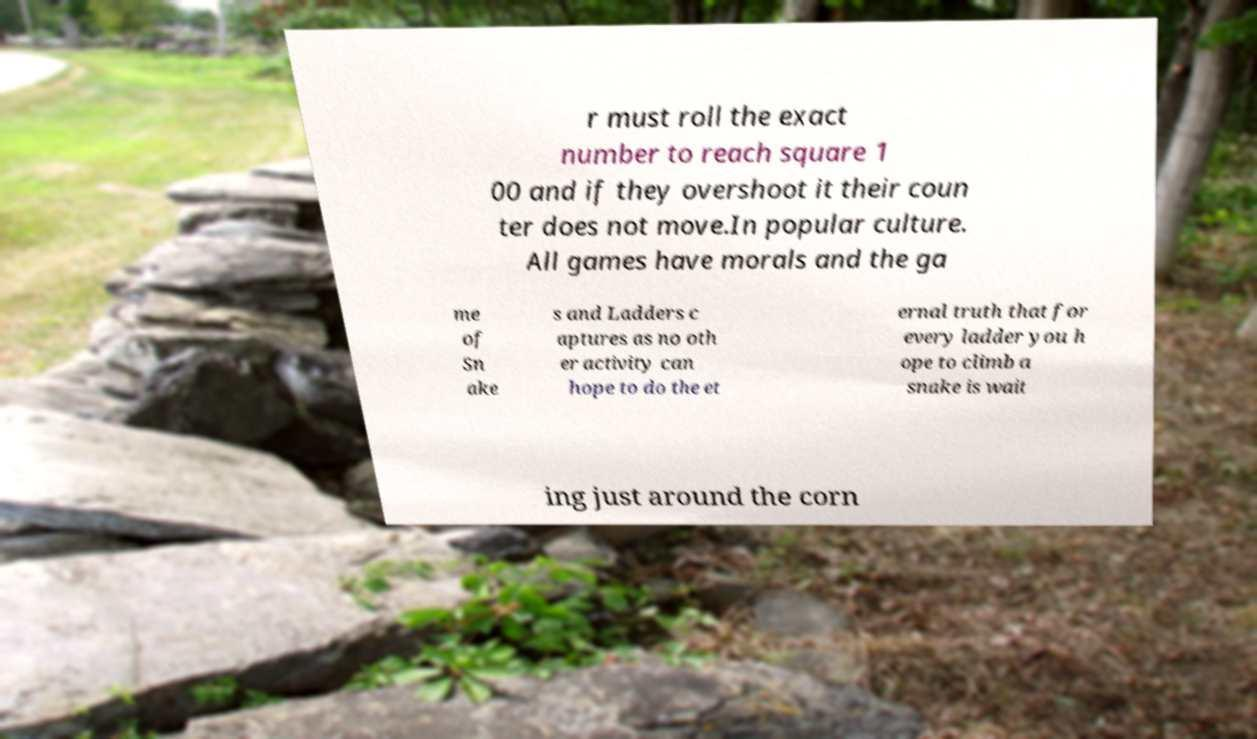I need the written content from this picture converted into text. Can you do that? r must roll the exact number to reach square 1 00 and if they overshoot it their coun ter does not move.In popular culture. All games have morals and the ga me of Sn ake s and Ladders c aptures as no oth er activity can hope to do the et ernal truth that for every ladder you h ope to climb a snake is wait ing just around the corn 